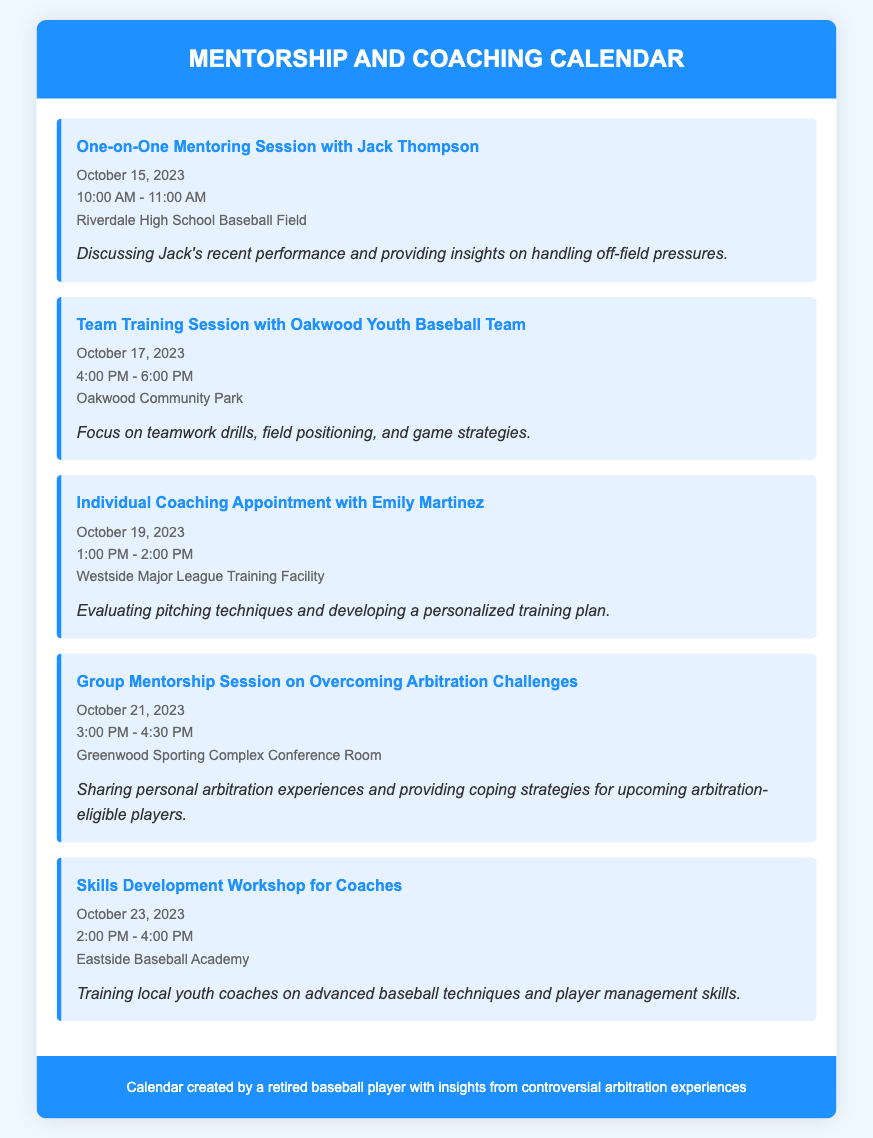What is the date of the one-on-one mentoring session with Jack Thompson? The document lists the event associated with Jack Thompson, which is scheduled for October 15, 2023.
Answer: October 15, 2023 What time does the team training session with the Oakwood Youth Baseball Team start? The training session is detailed to begin at 4:00 PM.
Answer: 4:00 PM Where is the individual coaching appointment with Emily Martinez taking place? The appointment location specified in the document is the Westside Major League Training Facility.
Answer: Westside Major League Training Facility How long is the group mentorship session on overcoming arbitration challenges? The document indicates the session lasts for 1.5 hours, from 3:00 PM to 4:30 PM.
Answer: 1.5 hours What is the focus of the skills development workshop for coaches? The document states that the workshop is aimed at training local youth coaches on advanced baseball techniques and player management skills.
Answer: Advanced baseball techniques and player management skills How many events are scheduled in total? By counting the events listed in the calendar, there are a total of five events stated.
Answer: Five events What is the event happening on October 21, 2023? The document specifies the event on that date as a group mentorship session on overcoming arbitration challenges.
Answer: Group mentorship session on overcoming arbitration challenges What type of location is the Greenwood Sporting Complex? The document informs that the session on arbitration challenges will take place in the conference room at the complex.
Answer: Conference room What is the purpose of the one-on-one mentoring session with Jack Thompson? The document clarifies that the session will discuss Jack's recent performance and provide insights on handling off-field pressures.
Answer: Handling off-field pressures 